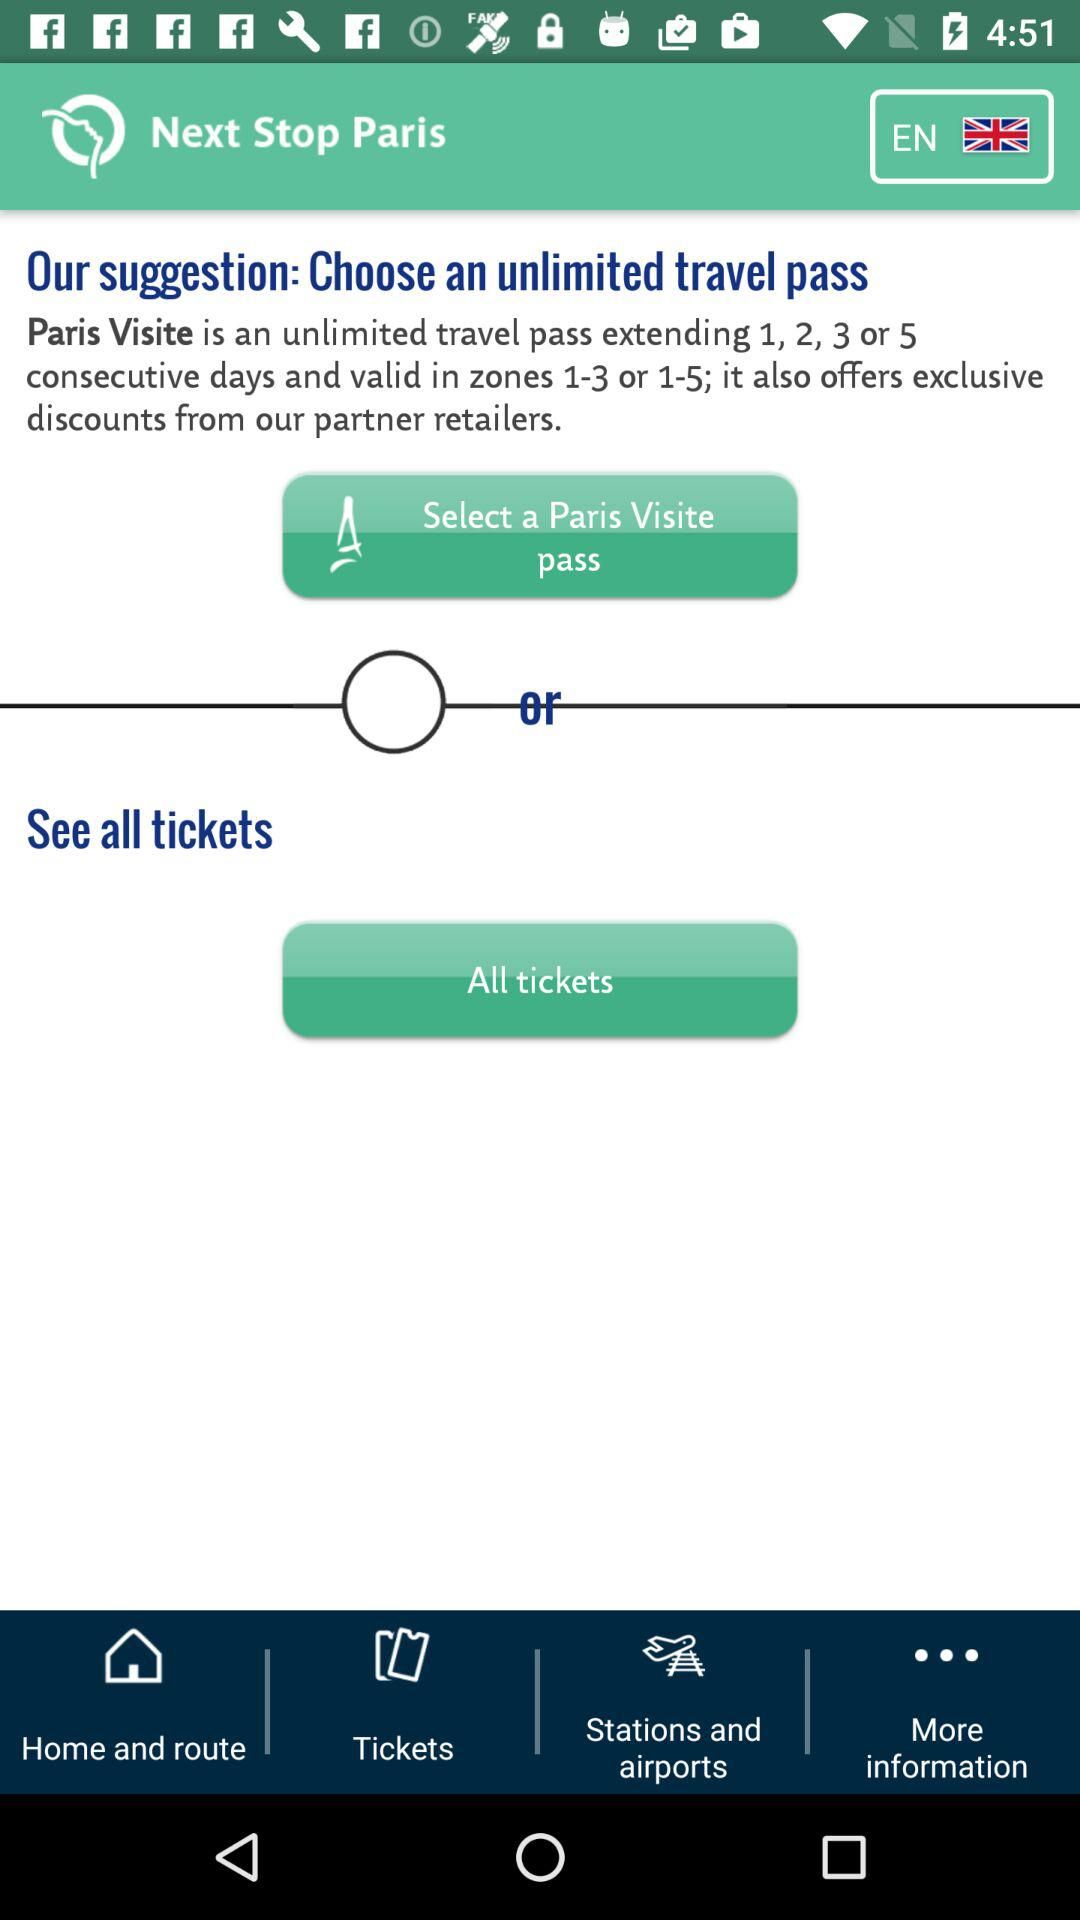For how many days the Paris Visitie pass is valid?
When the provided information is insufficient, respond with <no answer>. <no answer> 